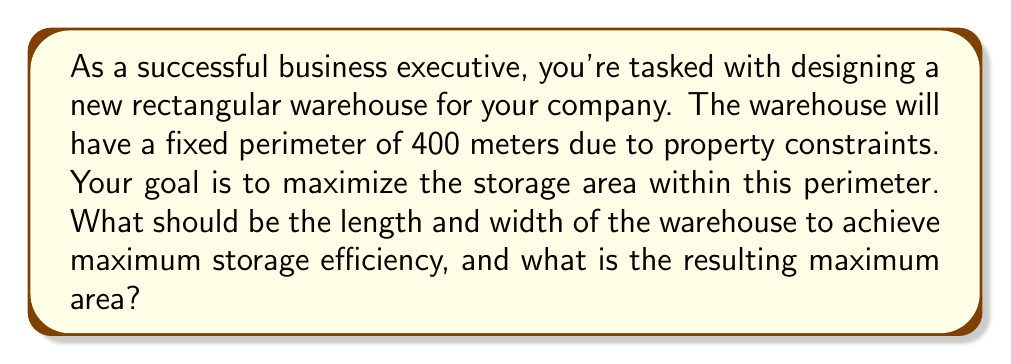Give your solution to this math problem. Let's approach this step-by-step:

1) Let the width of the warehouse be $w$ and the length be $l$.

2) Given that the perimeter is fixed at 400 meters, we can write:
   $$2w + 2l = 400$$

3) Solving for $l$:
   $$l = 200 - w$$

4) The area $A$ of the warehouse is given by:
   $$A = w \cdot l = w(200 - w) = 200w - w^2$$

5) To find the maximum area, we need to find the vertex of this quadratic function. We can do this by differentiating $A$ with respect to $w$ and setting it to zero:

   $$\frac{dA}{dw} = 200 - 2w$$
   
   $$200 - 2w = 0$$
   $$2w = 200$$
   $$w = 100$$

6) The second derivative is negative $(\frac{d^2A}{dw^2} = -2)$, confirming this is a maximum.

7) If $w = 100$, then $l = 200 - 100 = 100$.

8) The maximum area is therefore:
   $$A = 100 \cdot 100 = 10,000 \text{ square meters}$$

[asy]
size(200);
draw((0,0)--(100,0)--(100,100)--(0,100)--cycle);
label("100 m", (50,0), S);
label("100 m", (0,50), W);
label("Area = 10,000 sq m", (50,50));
[/asy]
Answer: The optimal dimensions for the warehouse are 100 meters by 100 meters, resulting in a maximum area of 10,000 square meters. 